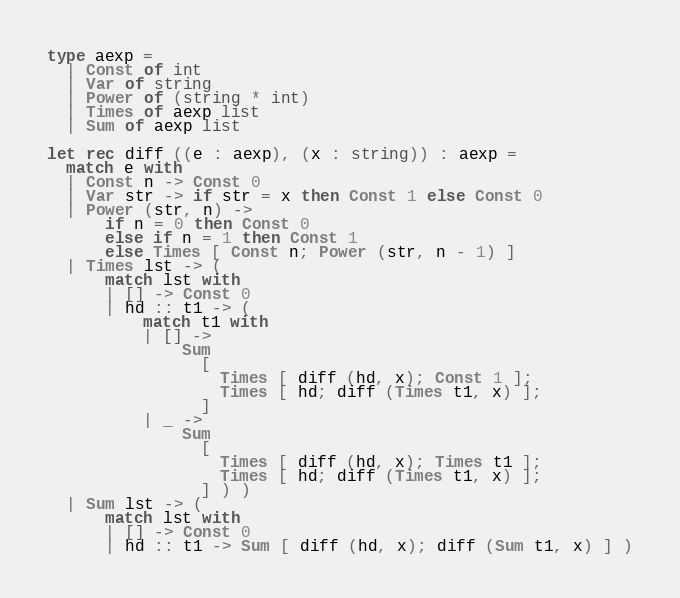<code> <loc_0><loc_0><loc_500><loc_500><_OCaml_>type aexp =
  | Const of int
  | Var of string
  | Power of (string * int)
  | Times of aexp list
  | Sum of aexp list

let rec diff ((e : aexp), (x : string)) : aexp =
  match e with
  | Const n -> Const 0
  | Var str -> if str = x then Const 1 else Const 0
  | Power (str, n) ->
      if n = 0 then Const 0
      else if n = 1 then Const 1
      else Times [ Const n; Power (str, n - 1) ]
  | Times lst -> (
      match lst with
      | [] -> Const 0
      | hd :: t1 -> (
          match t1 with
          | [] ->
              Sum
                [
                  Times [ diff (hd, x); Const 1 ];
                  Times [ hd; diff (Times t1, x) ];
                ]
          | _ ->
              Sum
                [
                  Times [ diff (hd, x); Times t1 ];
                  Times [ hd; diff (Times t1, x) ];
                ] ) )
  | Sum lst -> (
      match lst with
      | [] -> Const 0
      | hd :: t1 -> Sum [ diff (hd, x); diff (Sum t1, x) ] )
</code> 